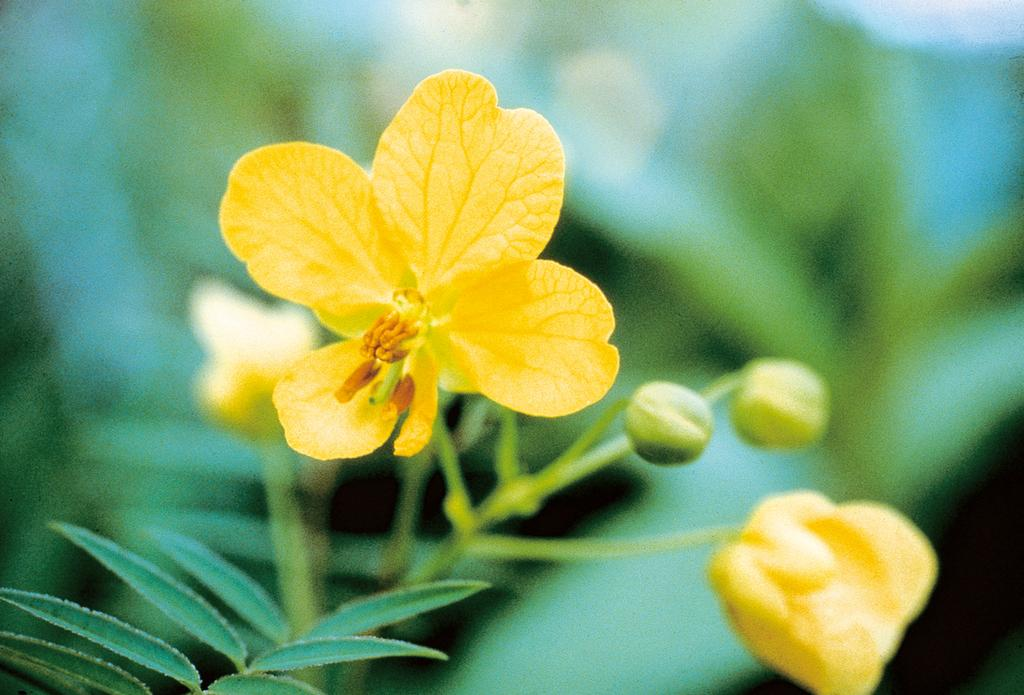What type of plant is featured in the image? There is a plant with flowers in the image. What color are the flowers on the plant? The flowers are yellow in color. Are there any unopened flowers on the plant? Yes, there are flower buds on the plant. Can you describe the plants visible in the background? The plants visible in the background are not clearly visible, so it is difficult to describe them. What memory does the plant have of its past experiences? Plants do not have memories or past experiences, so this question cannot be answered. 